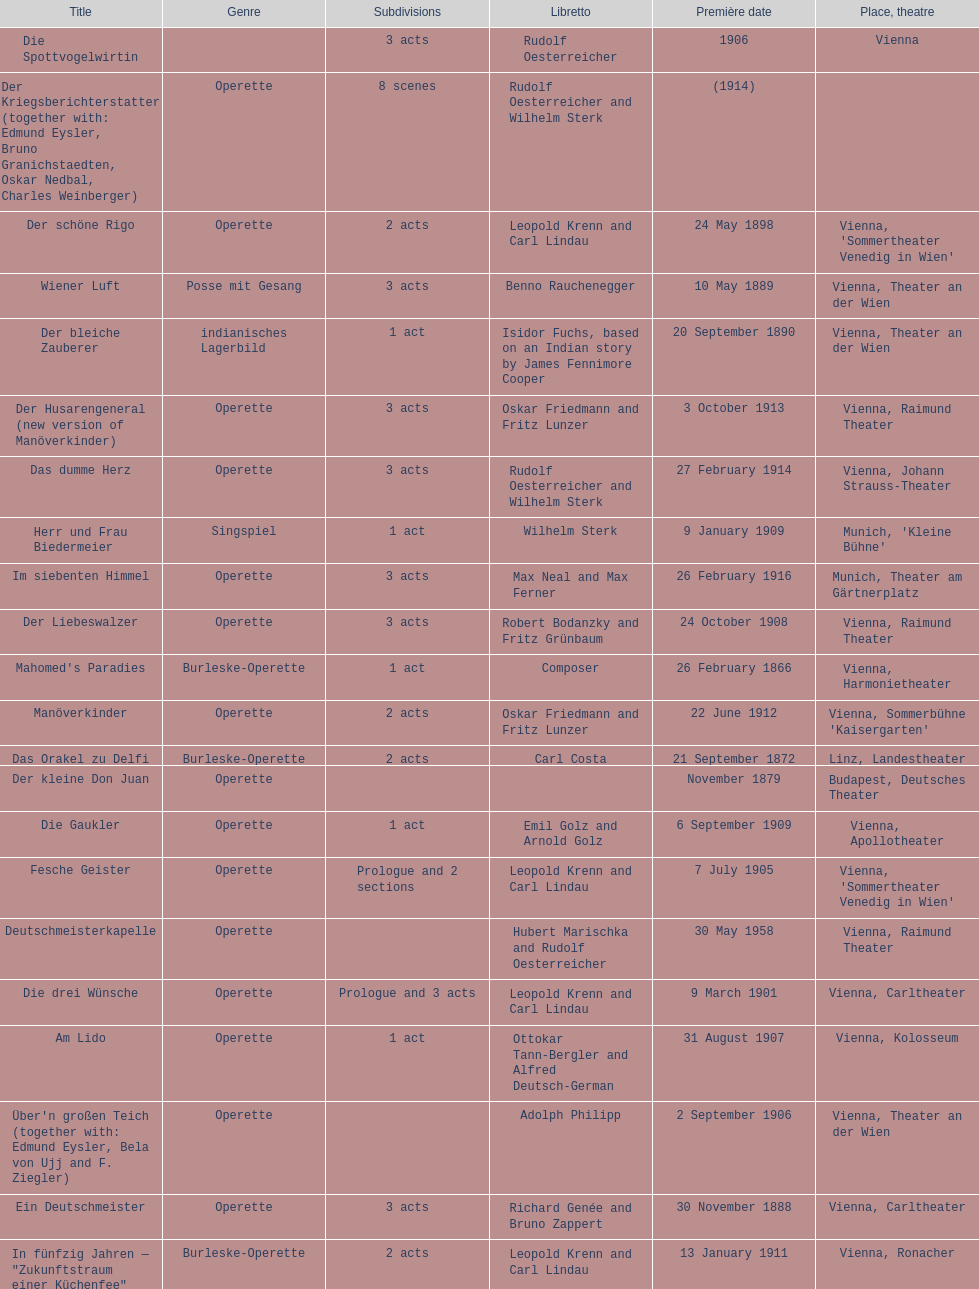How many number of 1 acts were there? 5. 